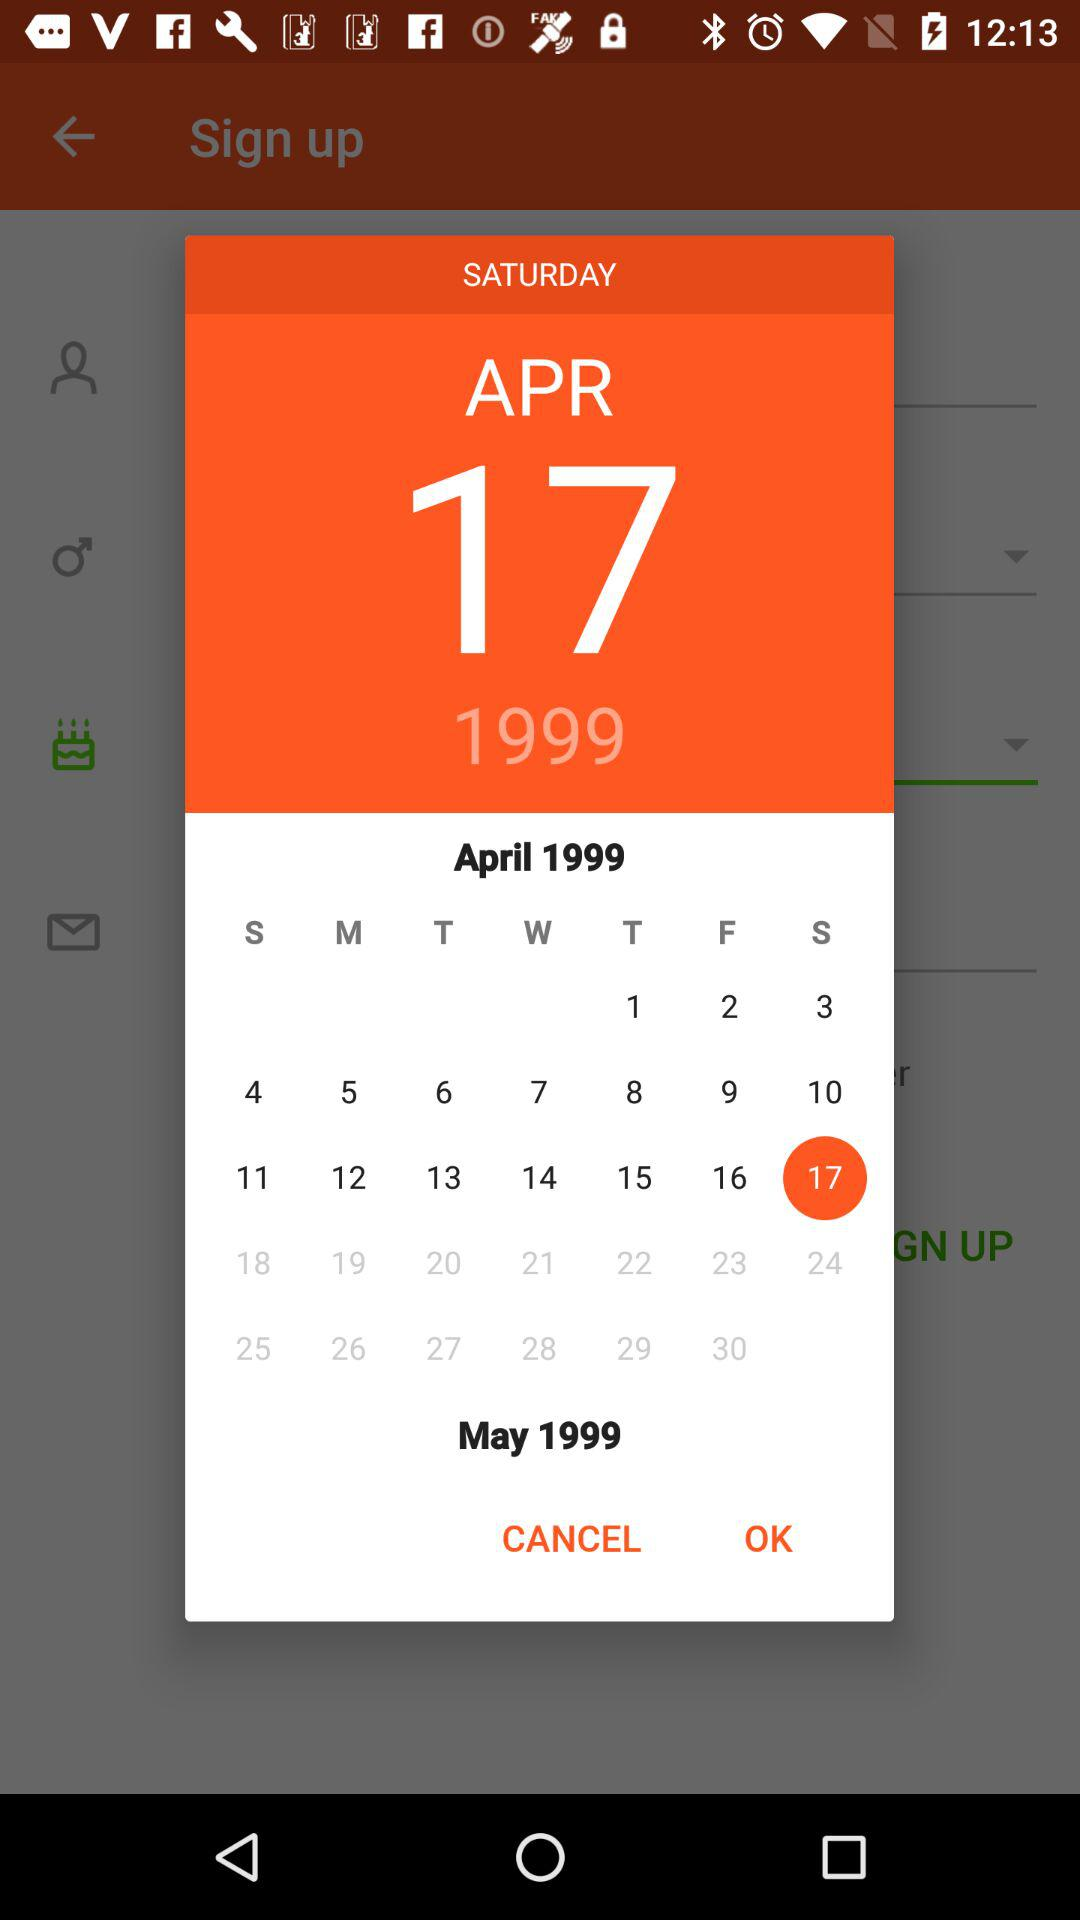What is the selected date? The selected date is Saturday, April 17, 1999. 